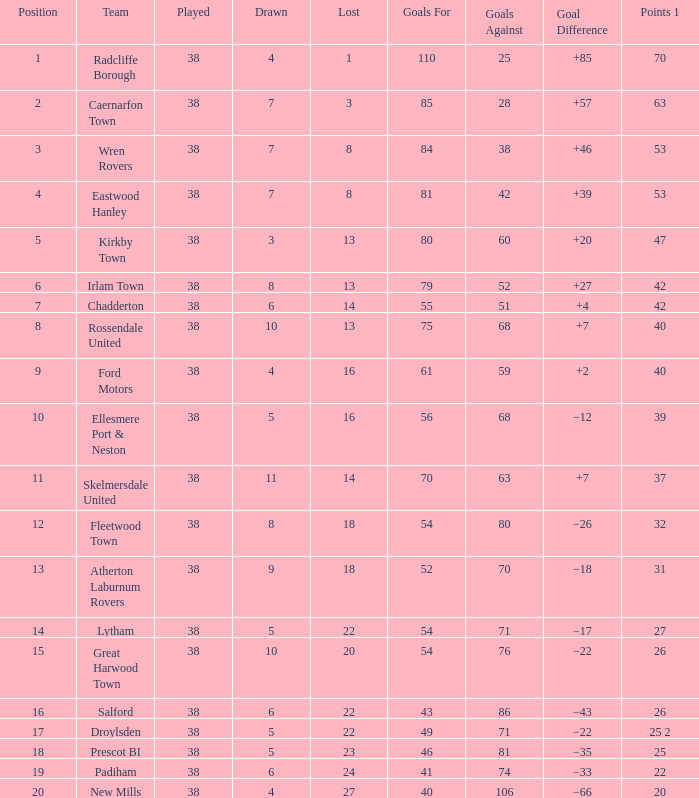Which lost has a position greater than 5, with 1 point out of 37, and fewer than 63 goals against? None. 